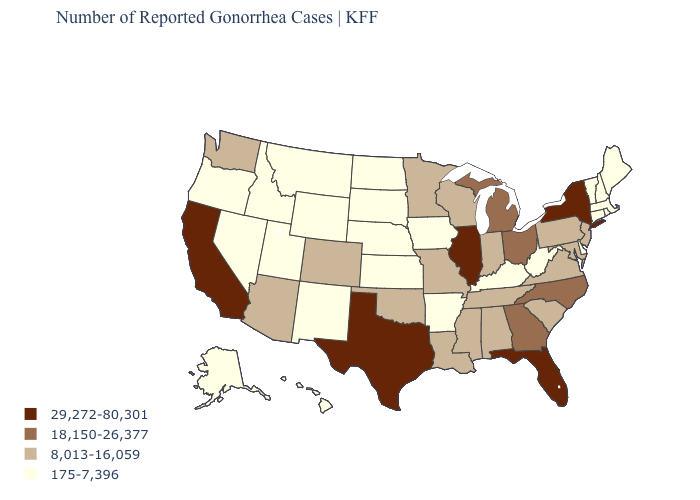Does Michigan have the lowest value in the USA?
Write a very short answer. No. What is the value of California?
Give a very brief answer. 29,272-80,301. Does the first symbol in the legend represent the smallest category?
Answer briefly. No. Is the legend a continuous bar?
Write a very short answer. No. What is the highest value in states that border Oklahoma?
Concise answer only. 29,272-80,301. Name the states that have a value in the range 8,013-16,059?
Give a very brief answer. Alabama, Arizona, Colorado, Indiana, Louisiana, Maryland, Minnesota, Mississippi, Missouri, New Jersey, Oklahoma, Pennsylvania, South Carolina, Tennessee, Virginia, Washington, Wisconsin. Name the states that have a value in the range 8,013-16,059?
Quick response, please. Alabama, Arizona, Colorado, Indiana, Louisiana, Maryland, Minnesota, Mississippi, Missouri, New Jersey, Oklahoma, Pennsylvania, South Carolina, Tennessee, Virginia, Washington, Wisconsin. Name the states that have a value in the range 8,013-16,059?
Be succinct. Alabama, Arizona, Colorado, Indiana, Louisiana, Maryland, Minnesota, Mississippi, Missouri, New Jersey, Oklahoma, Pennsylvania, South Carolina, Tennessee, Virginia, Washington, Wisconsin. Does Nevada have the highest value in the USA?
Answer briefly. No. What is the value of North Dakota?
Short answer required. 175-7,396. What is the value of Iowa?
Quick response, please. 175-7,396. What is the highest value in the West ?
Concise answer only. 29,272-80,301. Which states have the lowest value in the USA?
Concise answer only. Alaska, Arkansas, Connecticut, Delaware, Hawaii, Idaho, Iowa, Kansas, Kentucky, Maine, Massachusetts, Montana, Nebraska, Nevada, New Hampshire, New Mexico, North Dakota, Oregon, Rhode Island, South Dakota, Utah, Vermont, West Virginia, Wyoming. Name the states that have a value in the range 175-7,396?
Keep it brief. Alaska, Arkansas, Connecticut, Delaware, Hawaii, Idaho, Iowa, Kansas, Kentucky, Maine, Massachusetts, Montana, Nebraska, Nevada, New Hampshire, New Mexico, North Dakota, Oregon, Rhode Island, South Dakota, Utah, Vermont, West Virginia, Wyoming. What is the value of Arizona?
Short answer required. 8,013-16,059. 